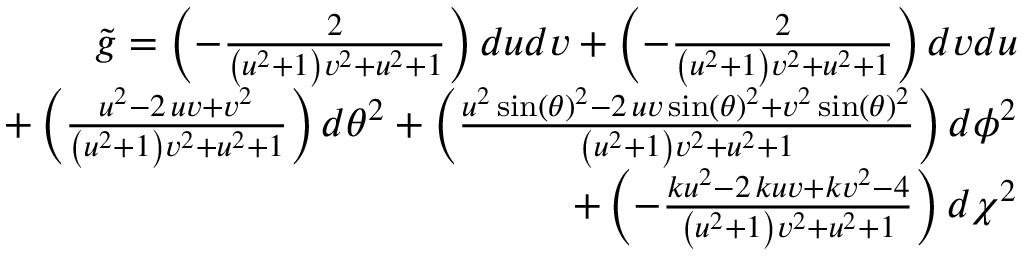Convert formula to latex. <formula><loc_0><loc_0><loc_500><loc_500>\begin{array} { r } { \tilde { g } = \left ( - \frac { 2 } { { \left ( u ^ { 2 } + 1 \right ) } v ^ { 2 } + u ^ { 2 } + 1 } \right ) d u d v + \left ( - \frac { 2 } { { \left ( u ^ { 2 } + 1 \right ) } v ^ { 2 } + u ^ { 2 } + 1 } \right ) d v d u } \\ { + \left ( \frac { u ^ { 2 } - 2 \, u v + v ^ { 2 } } { { \left ( u ^ { 2 } + 1 \right ) } v ^ { 2 } + u ^ { 2 } + 1 } \right ) d \theta ^ { 2 } + \left ( \frac { u ^ { 2 } \sin \left ( { \theta } \right ) ^ { 2 } - 2 \, u v \sin \left ( { \theta } \right ) ^ { 2 } + v ^ { 2 } \sin \left ( { \theta } \right ) ^ { 2 } } { { \left ( u ^ { 2 } + 1 \right ) } v ^ { 2 } + u ^ { 2 } + 1 } \right ) d \phi ^ { 2 } } \\ { + \left ( - \frac { k u ^ { 2 } - 2 \, k u v + k v ^ { 2 } - 4 } { { \left ( u ^ { 2 } + 1 \right ) } v ^ { 2 } + u ^ { 2 } + 1 } \right ) d \chi ^ { 2 } } \end{array}</formula> 